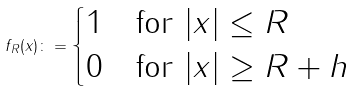Convert formula to latex. <formula><loc_0><loc_0><loc_500><loc_500>f _ { R } ( x ) \colon = \begin{cases} 1 & \text {for $|x|\leq R$} \\ 0 & \text {for $|x|\geq R+h$} \end{cases}</formula> 